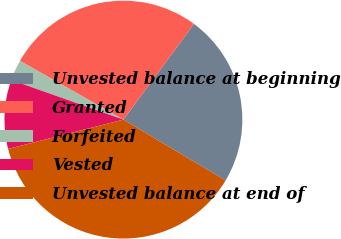<chart> <loc_0><loc_0><loc_500><loc_500><pie_chart><fcel>Unvested balance at beginning<fcel>Granted<fcel>Forfeited<fcel>Vested<fcel>Unvested balance at end of<nl><fcel>23.43%<fcel>26.9%<fcel>2.81%<fcel>9.37%<fcel>37.49%<nl></chart> 